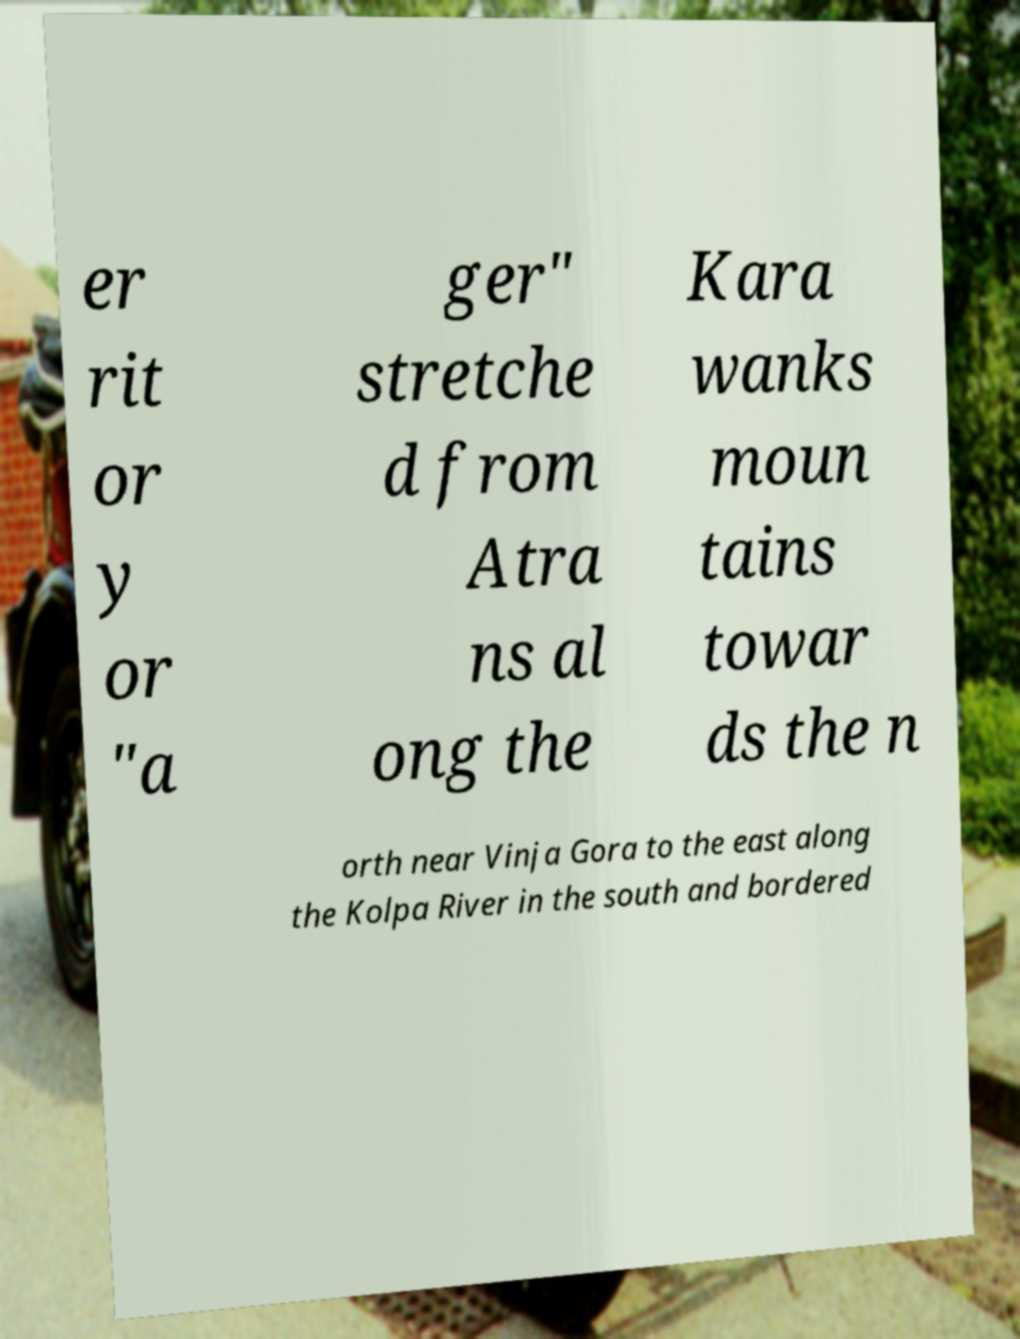Can you accurately transcribe the text from the provided image for me? er rit or y or "a ger" stretche d from Atra ns al ong the Kara wanks moun tains towar ds the n orth near Vinja Gora to the east along the Kolpa River in the south and bordered 